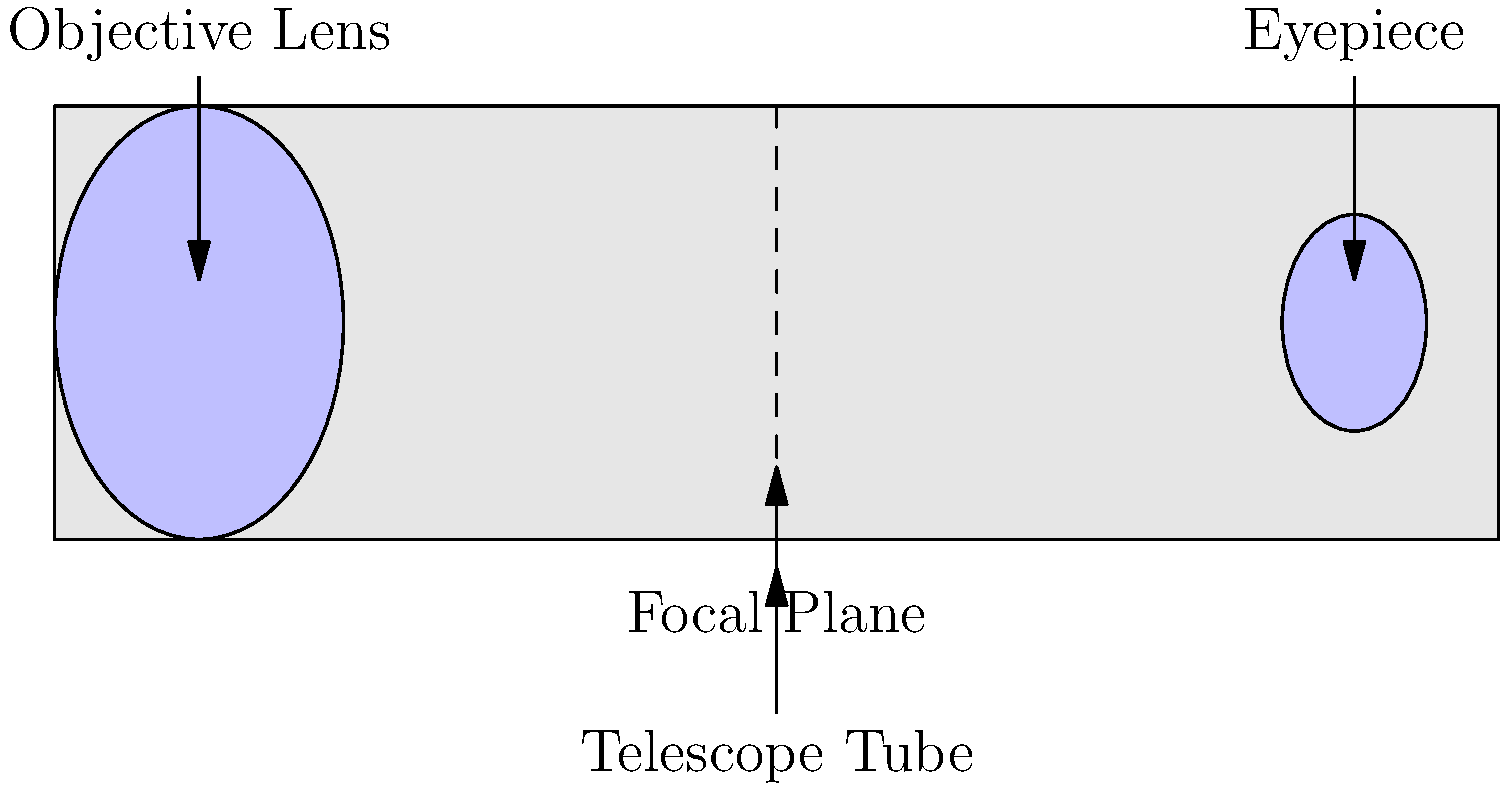As a product manager optimizing backend systems, you understand the importance of system components working together efficiently. In a refracting telescope, which component is responsible for gathering and focusing light from distant objects? To answer this question, let's break down the main components of a refracting telescope and their functions:

1. Telescope Tube: This is the main body of the telescope that houses all the optical components.

2. Objective Lens: Located at the front of the telescope, this large lens is responsible for gathering light from distant objects and focusing it to a point inside the telescope called the focal plane.

3. Focal Plane: This is where the image formed by the objective lens comes to a focus.

4. Eyepiece: A smaller lens or set of lenses near the focal plane that magnifies the image for viewing.

The key component for gathering and focusing light is the objective lens. Here's why:

1. Light Gathering: The large diameter of the objective lens allows it to collect more light than the human eye, making dim objects visible.

2. Focusing: The curved surface of the lens bends incoming light rays so that they converge at the focal plane, creating a clear image.

3. Image Formation: The objective lens is responsible for creating the primary image that is then magnified by the eyepiece.

In the context of system optimization, the objective lens can be compared to the data input and processing components of a backend system, which are crucial for gathering and organizing information before it's presented to the user (analogous to the eyepiece in a telescope).
Answer: Objective Lens 